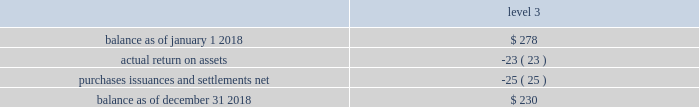Asset category target allocation total quoted prices in active markets for identical assets ( level 1 ) significant observable inputs ( level 2 ) significant unobservable inputs .
Balance as of january 1 , 2017 .
$ 140 actual return on assets .
2 purchases , issuances and settlements , net .
136 balance as of december 31 , 2017 .
$ 278 the company 2019s postretirement benefit plans have different levels of funded status and the assets are held under various trusts .
The investments and risk mitigation strategies for the plans are tailored specifically for each trust .
In setting new strategic asset mixes , consideration is given to the likelihood that the selected asset allocation will effectively fund the projected plan liabilities and meet the risk tolerance criteria of the company .
The company periodically updates the long-term , strategic asset allocations for these plans through asset liability studies and uses various analytics to determine the optimal asset allocation .
Considerations include plan liability characteristics , liquidity needs , funding requirements , expected rates of return and the distribution of returns .
In 2012 , the company implemented a de-risking strategy for the american water pension plan after conducting an asset-liability study to reduce the volatility of the funded status of the plan .
As part of the de-risking strategy , the company revised the asset allocations to increase the matching characteristics of fixed- income assets relative to liabilities .
The fixed income portion of the portfolio was designed to match the bond- .
By what percentage level 3 balance increase from 2017 to 2018? 
Computations: ((230 - 140) / 140)
Answer: 0.64286. 